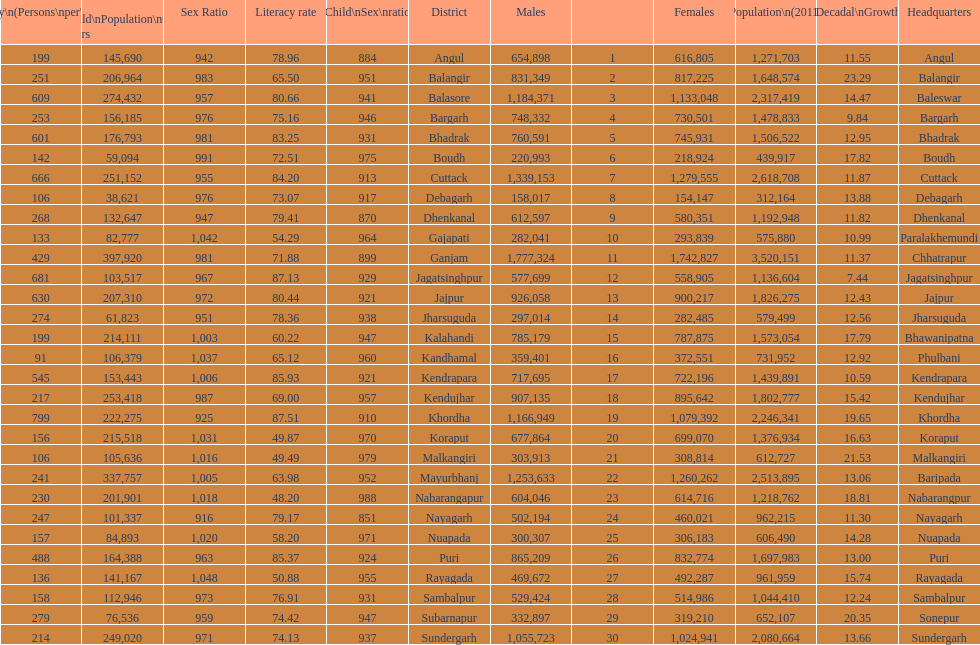What is the difference in child population between koraput and puri? 51,130. 